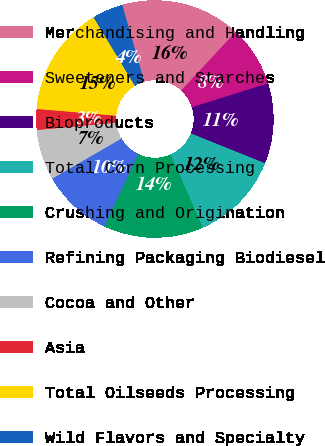Convert chart to OTSL. <chart><loc_0><loc_0><loc_500><loc_500><pie_chart><fcel>Merchandising and Handling<fcel>Sweeteners and Starches<fcel>Bioproducts<fcel>Total Corn Processing<fcel>Crushing and Origination<fcel>Refining Packaging Biodiesel<fcel>Cocoa and Other<fcel>Asia<fcel>Total Oilseeds Processing<fcel>Wild Flavors and Specialty<nl><fcel>16.35%<fcel>8.24%<fcel>10.95%<fcel>12.3%<fcel>13.65%<fcel>9.59%<fcel>6.89%<fcel>2.84%<fcel>15.0%<fcel>4.19%<nl></chart> 